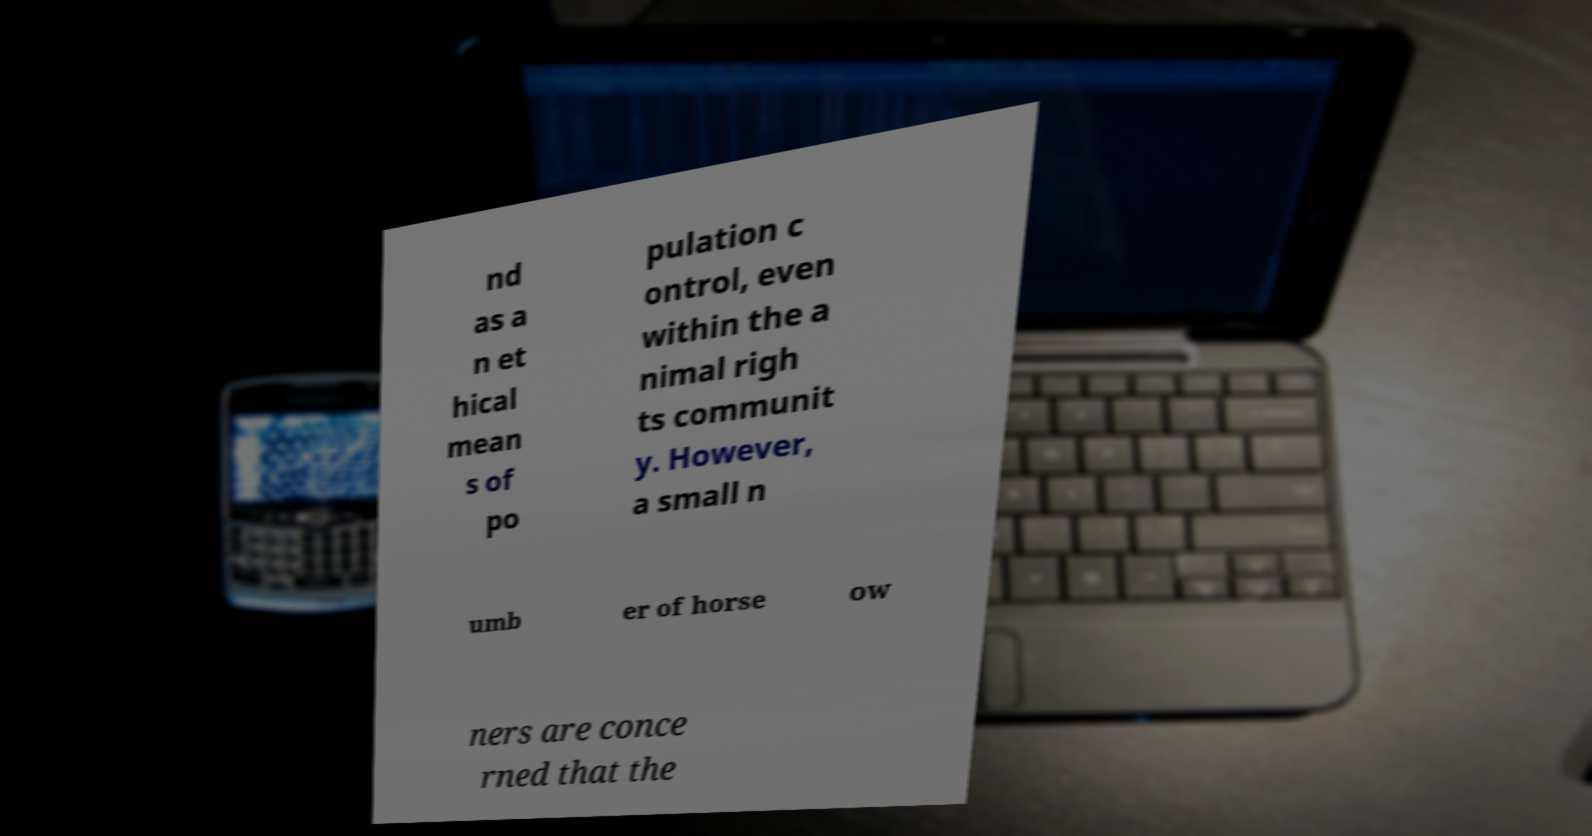I need the written content from this picture converted into text. Can you do that? nd as a n et hical mean s of po pulation c ontrol, even within the a nimal righ ts communit y. However, a small n umb er of horse ow ners are conce rned that the 